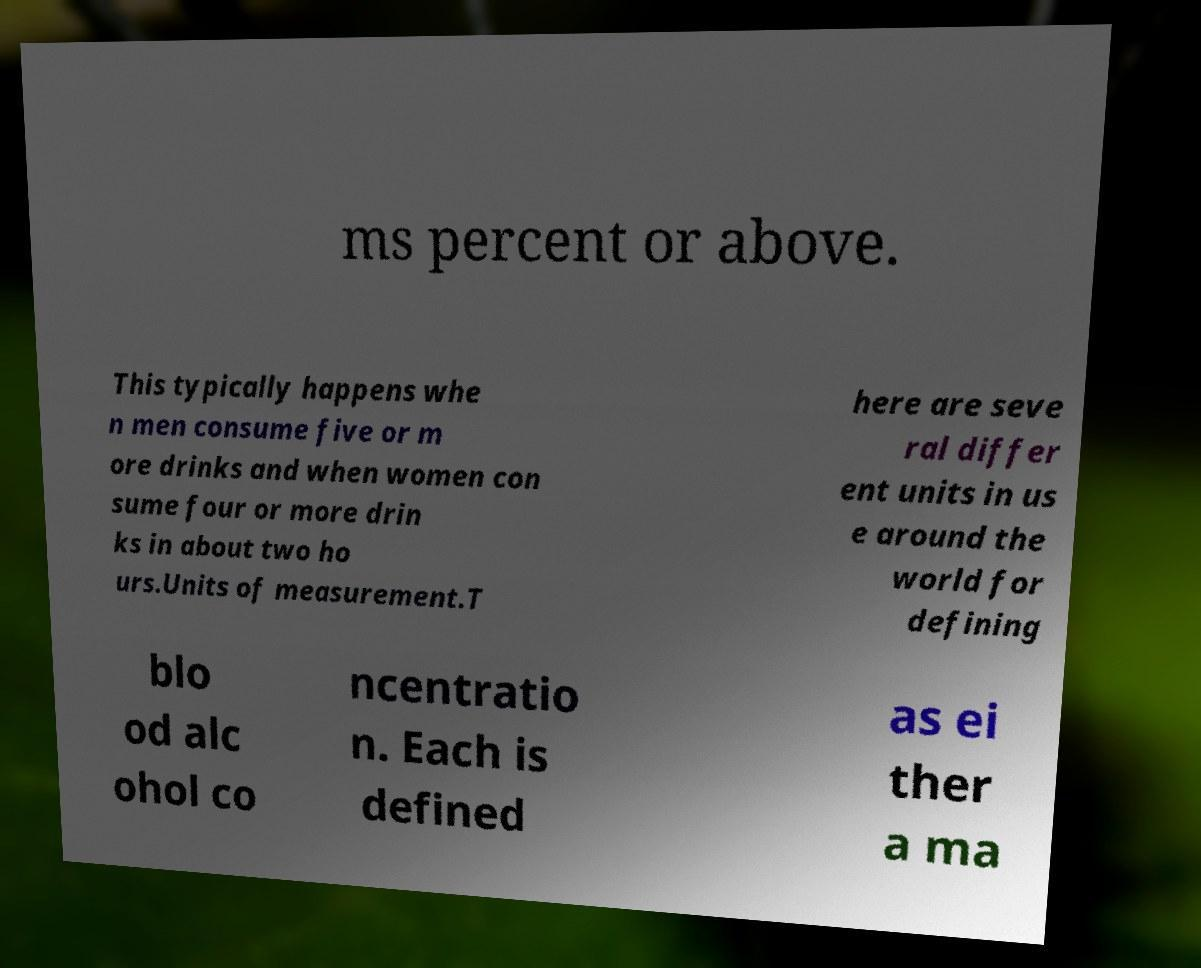There's text embedded in this image that I need extracted. Can you transcribe it verbatim? ms percent or above. This typically happens whe n men consume five or m ore drinks and when women con sume four or more drin ks in about two ho urs.Units of measurement.T here are seve ral differ ent units in us e around the world for defining blo od alc ohol co ncentratio n. Each is defined as ei ther a ma 